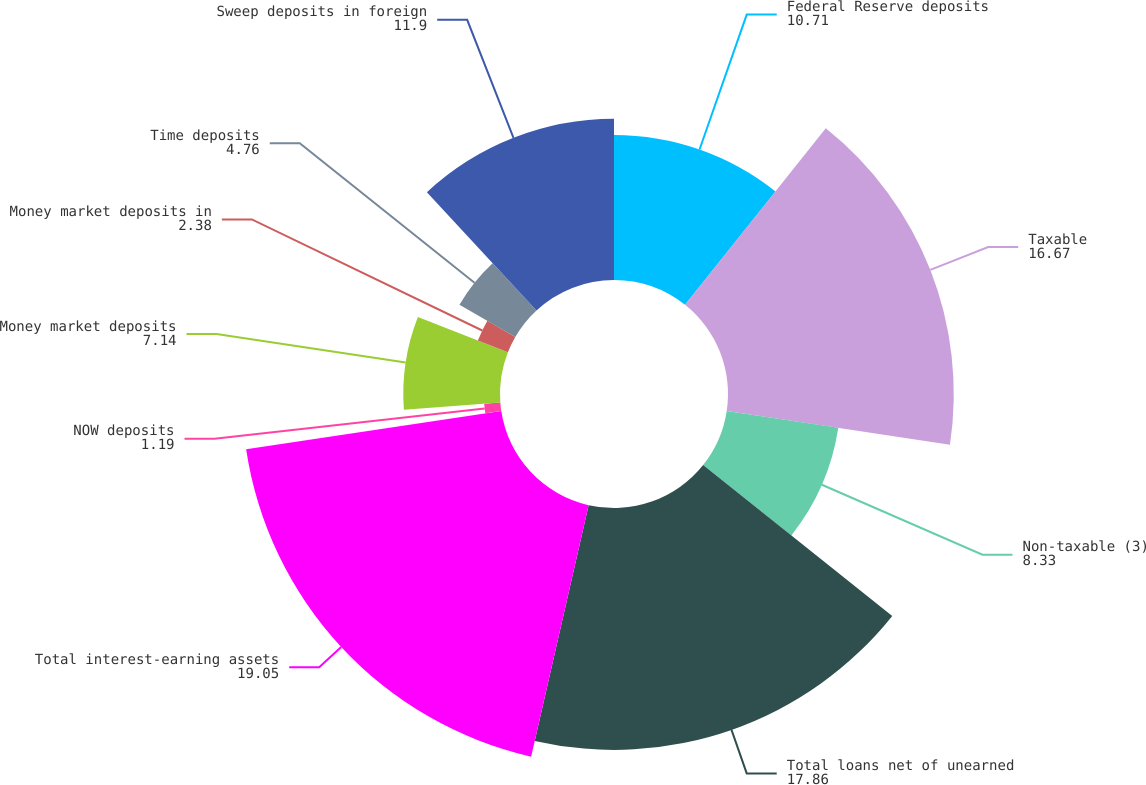Convert chart to OTSL. <chart><loc_0><loc_0><loc_500><loc_500><pie_chart><fcel>Federal Reserve deposits<fcel>Taxable<fcel>Non-taxable (3)<fcel>Total loans net of unearned<fcel>Total interest-earning assets<fcel>NOW deposits<fcel>Money market deposits<fcel>Money market deposits in<fcel>Time deposits<fcel>Sweep deposits in foreign<nl><fcel>10.71%<fcel>16.67%<fcel>8.33%<fcel>17.86%<fcel>19.05%<fcel>1.19%<fcel>7.14%<fcel>2.38%<fcel>4.76%<fcel>11.9%<nl></chart> 